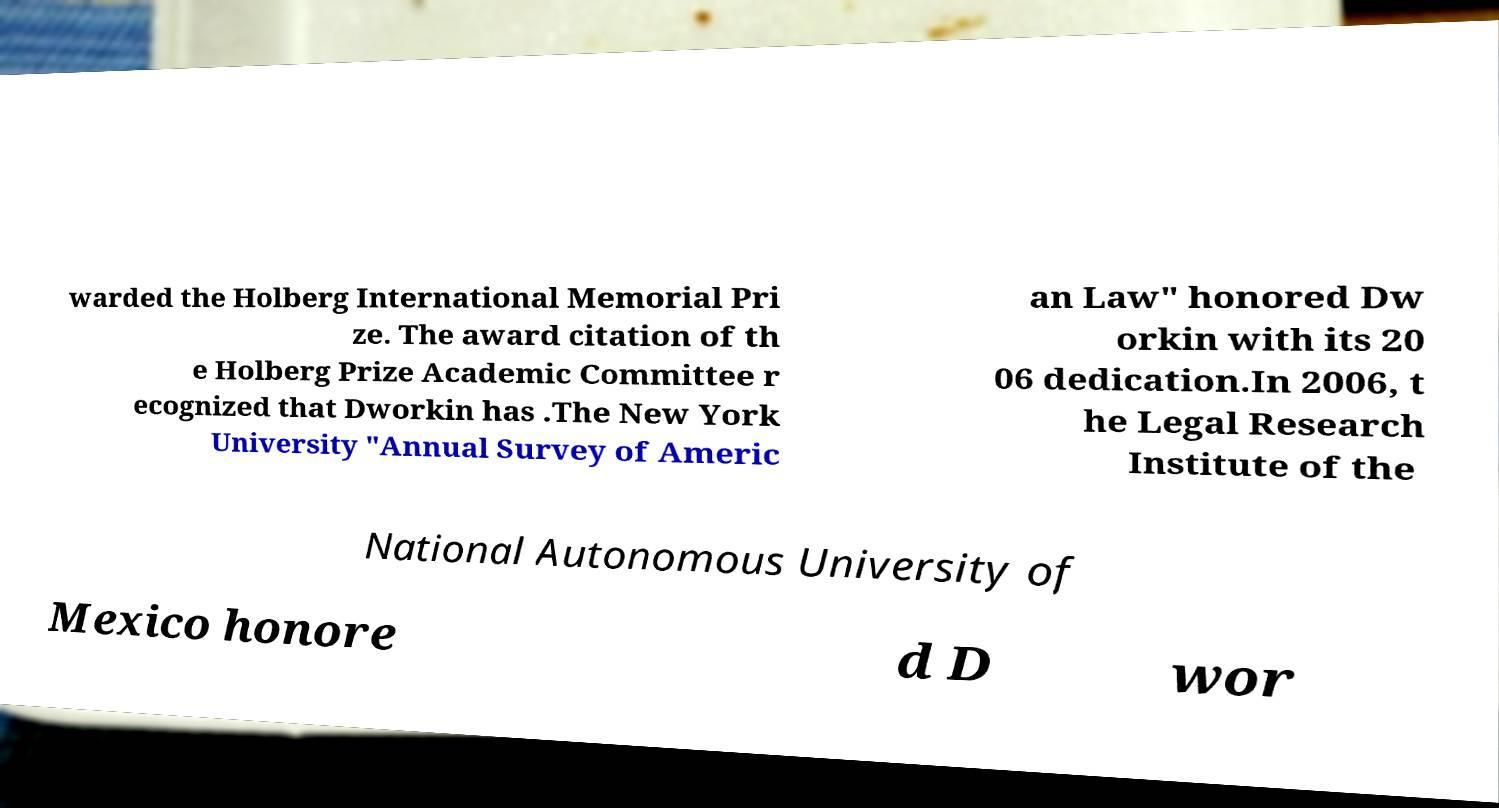Can you read and provide the text displayed in the image?This photo seems to have some interesting text. Can you extract and type it out for me? warded the Holberg International Memorial Pri ze. The award citation of th e Holberg Prize Academic Committee r ecognized that Dworkin has .The New York University "Annual Survey of Americ an Law" honored Dw orkin with its 20 06 dedication.In 2006, t he Legal Research Institute of the National Autonomous University of Mexico honore d D wor 